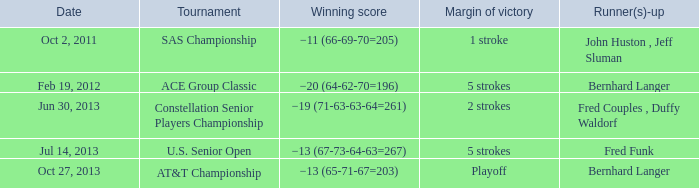Which Margin of victory has a Tournament of u.s. senior open? 5 strokes. 